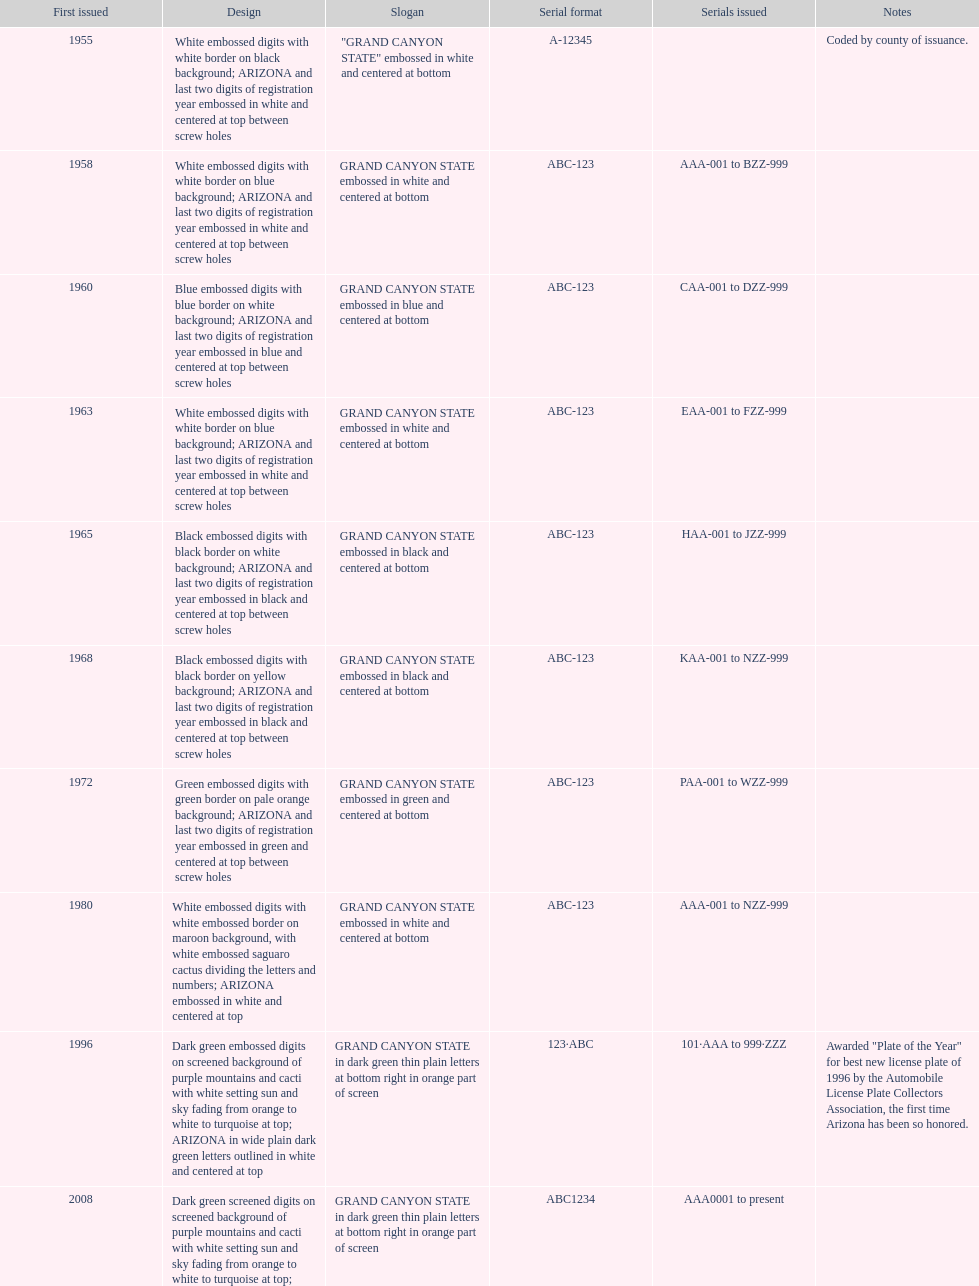Name the year of the license plate that has the largest amount of alphanumeric digits. 2008. 